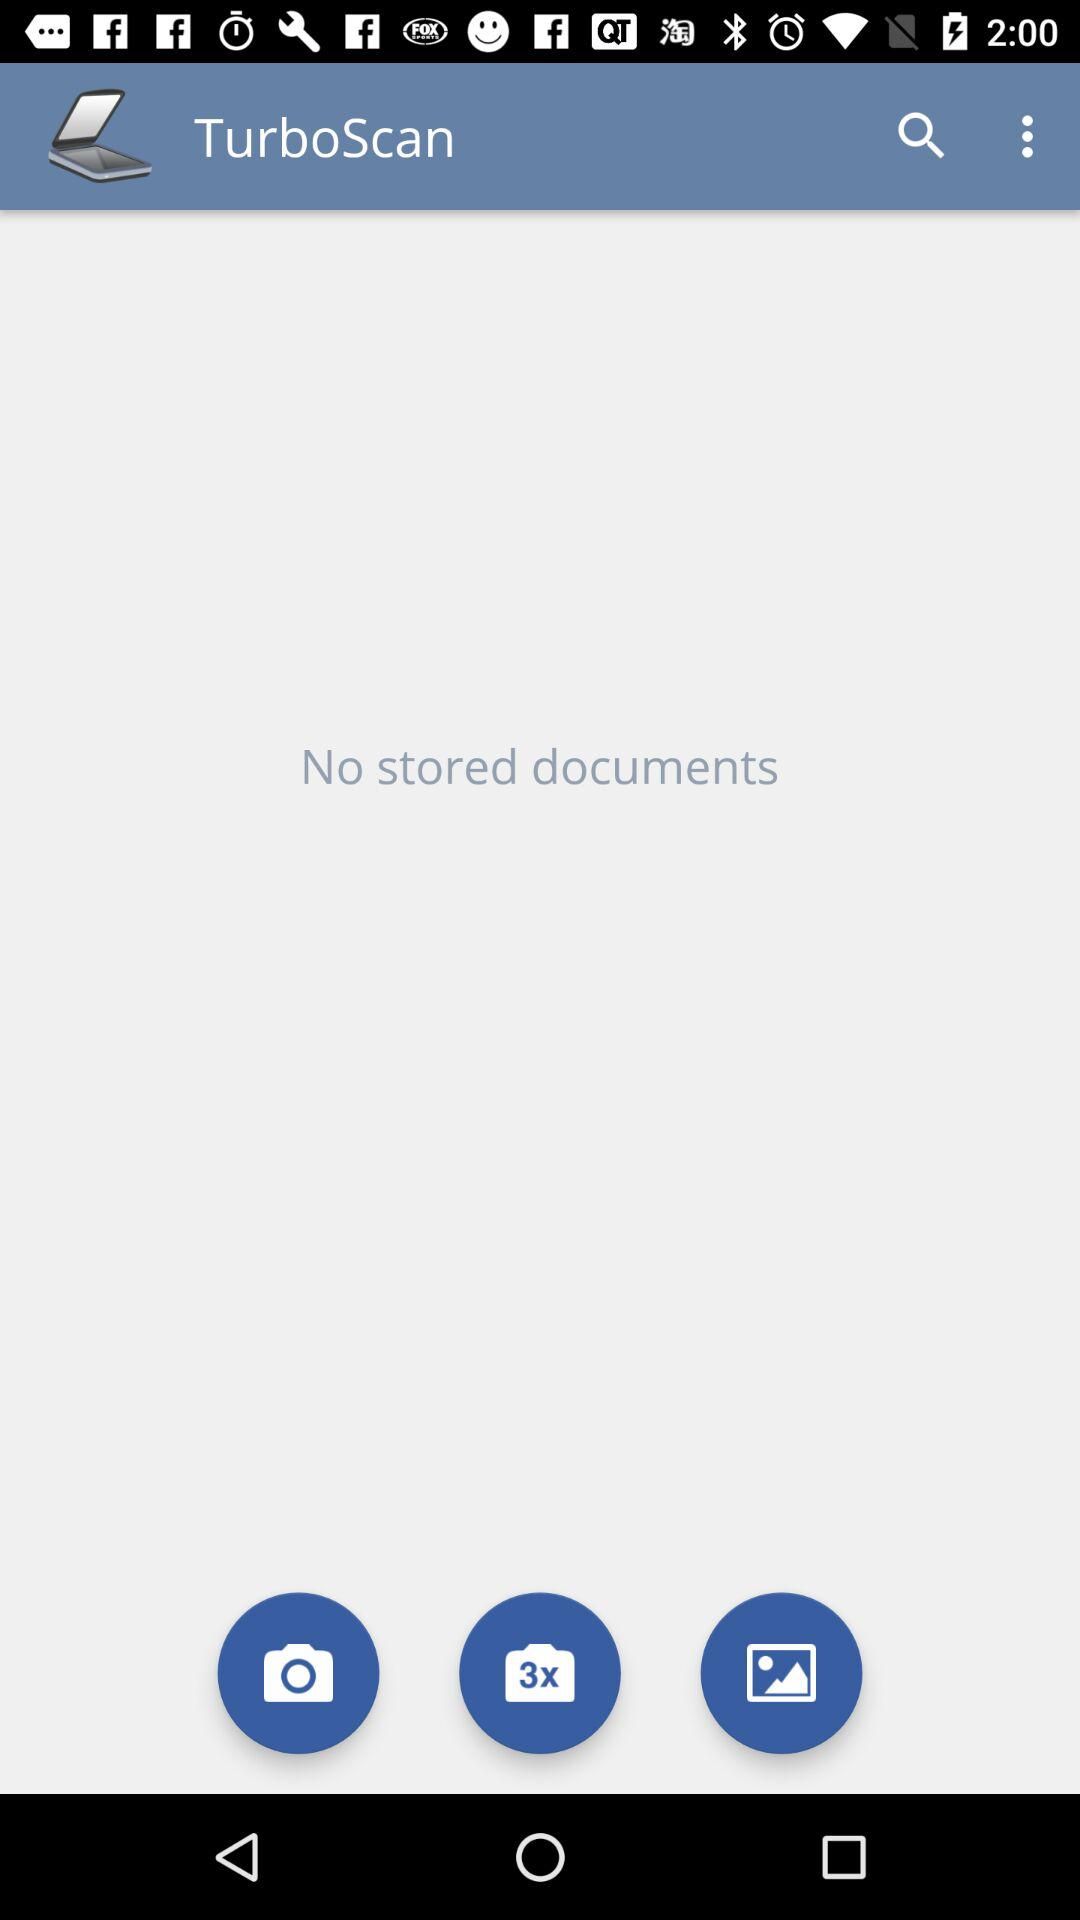Are there any documents stored? There are no stored documents. 